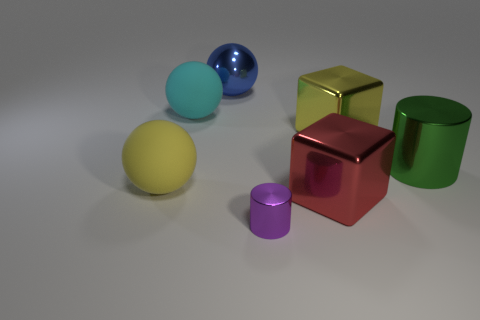Add 2 green things. How many objects exist? 9 Subtract all rubber balls. How many balls are left? 1 Subtract all cylinders. How many objects are left? 5 Subtract 0 gray cubes. How many objects are left? 7 Subtract all gray balls. Subtract all purple cylinders. How many balls are left? 3 Subtract all balls. Subtract all blue objects. How many objects are left? 3 Add 2 small metallic cylinders. How many small metallic cylinders are left? 3 Add 4 yellow matte things. How many yellow matte things exist? 5 